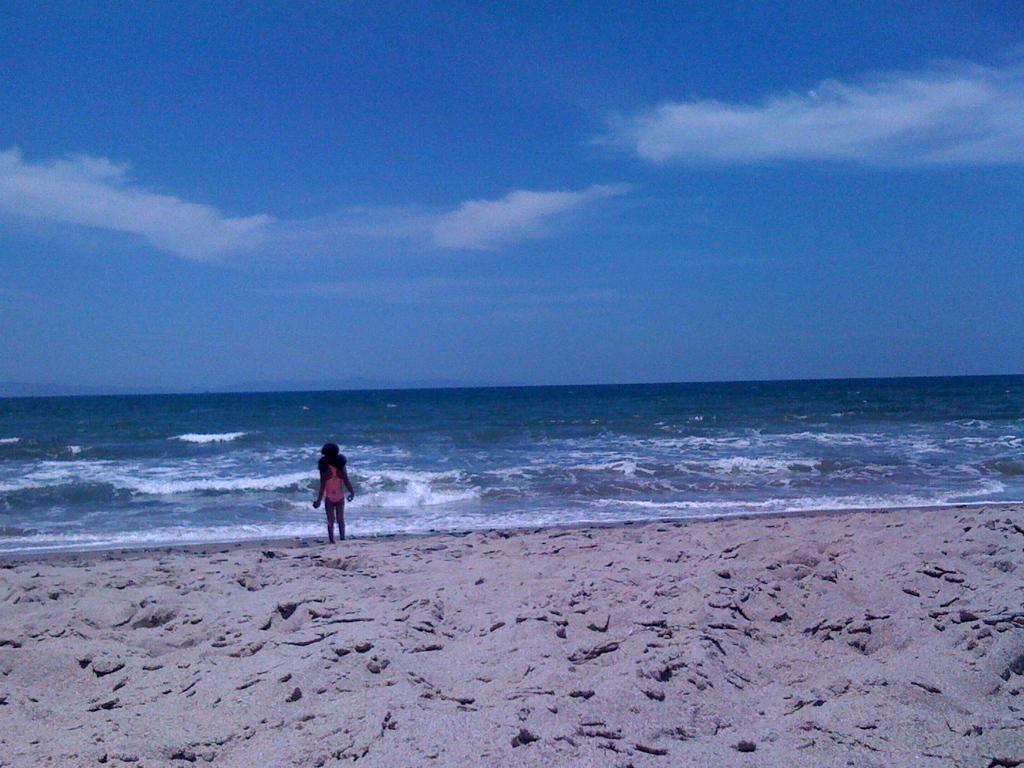What type of surface is in the foreground of the image? There is a sand surface in the foreground of the image. Can you describe the person in the image? There is a person in the image, but their appearance or actions are not specified. What type of location does the sand surface suggest? The sand surface suggests that the setting is a beach. What can be seen in the sky in the image? The sky is visible in the image, but its specific appearance or weather conditions are not specified. How many spiders are crawling on the person in the image? There is no mention of spiders in the image, so we cannot determine their presence or number. What type of story is being told by the person in the image? There is no indication of a story being told in the image, as the person's actions or expressions are not specified. 